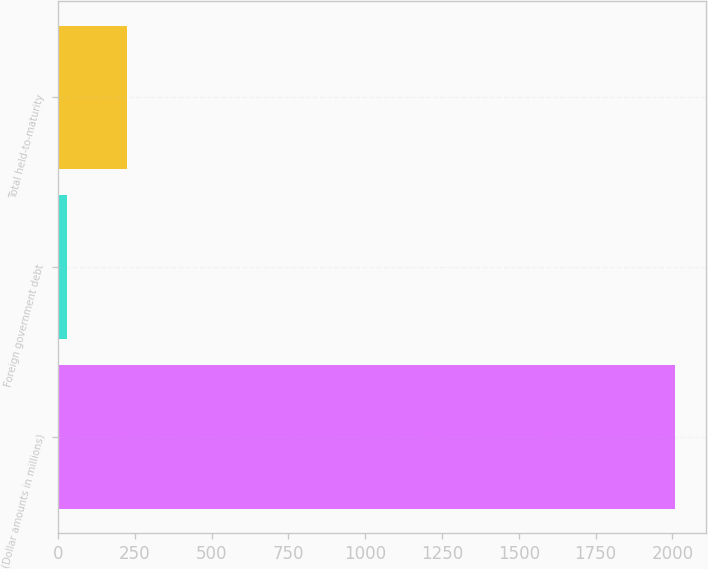Convert chart to OTSL. <chart><loc_0><loc_0><loc_500><loc_500><bar_chart><fcel>(Dollar amounts in millions)<fcel>Foreign government debt<fcel>Total held-to-maturity<nl><fcel>2009<fcel>28<fcel>226.1<nl></chart> 